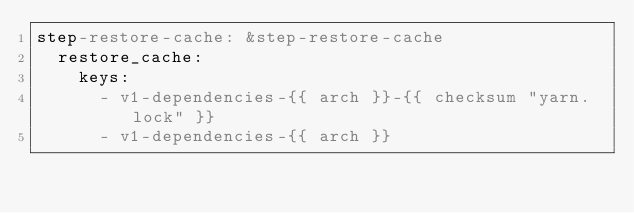Convert code to text. <code><loc_0><loc_0><loc_500><loc_500><_YAML_>step-restore-cache: &step-restore-cache
  restore_cache:
    keys:
      - v1-dependencies-{{ arch }}-{{ checksum "yarn.lock" }}
      - v1-dependencies-{{ arch }}
</code> 